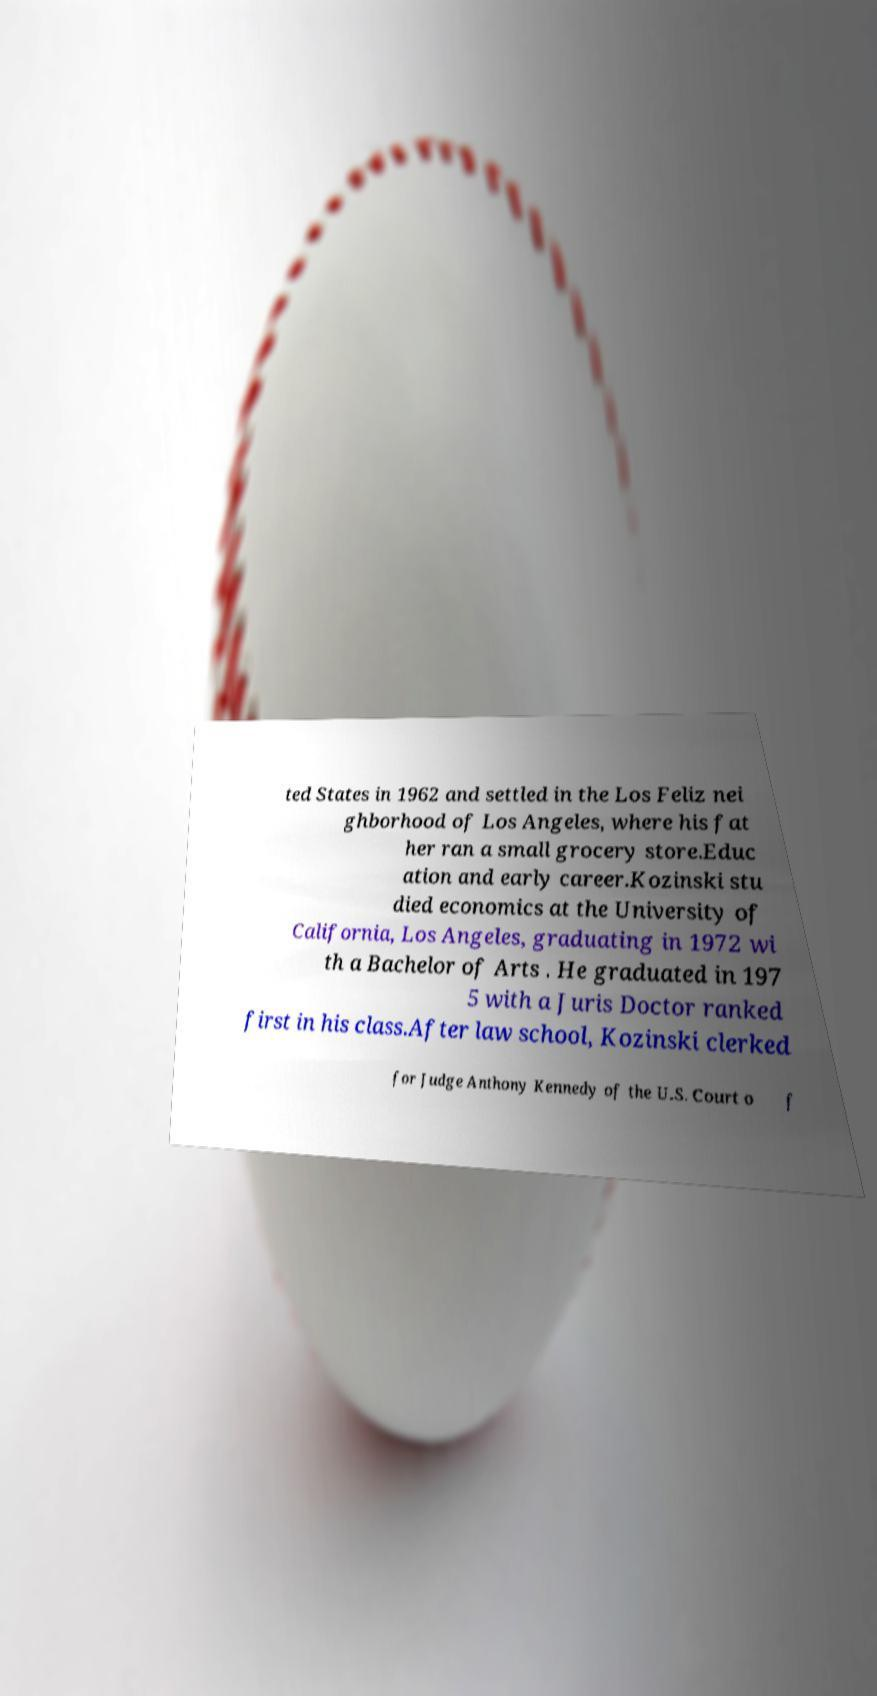Could you assist in decoding the text presented in this image and type it out clearly? ted States in 1962 and settled in the Los Feliz nei ghborhood of Los Angeles, where his fat her ran a small grocery store.Educ ation and early career.Kozinski stu died economics at the University of California, Los Angeles, graduating in 1972 wi th a Bachelor of Arts . He graduated in 197 5 with a Juris Doctor ranked first in his class.After law school, Kozinski clerked for Judge Anthony Kennedy of the U.S. Court o f 